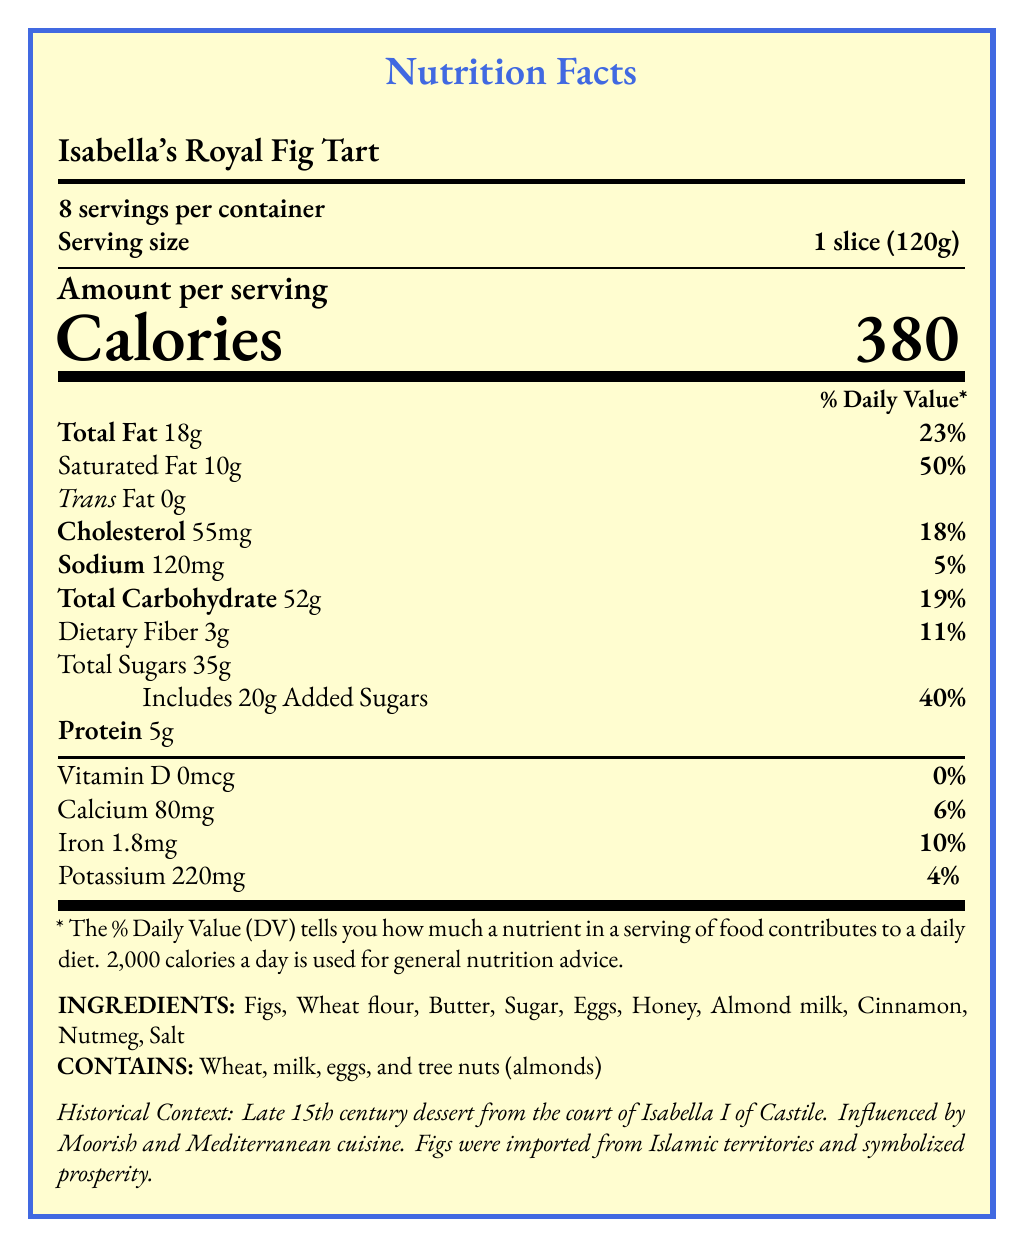what is the serving size? The serving size is clearly stated in the document as 1 slice (120g).
Answer: 1 slice (120g) how many calories are in one serving? The document specifies that each serving contains 380 calories.
Answer: 380 List three main ingredients in Isabella's Royal Fig Tart. The ingredients are listed in the document, and three of the main ones are Figs, Wheat flour, and Butter.
Answer: Figs, Wheat flour, Butter what percentage of the daily value for saturated fat does one serving provide? The document states that one serving contains 10g of saturated fat which is 50% of the daily value.
Answer: 50% what is the historical context of Isabella's Royal Fig Tart? The document includes a section on historical context which details that this tart was a late 15th-century dessert from the court of Isabella I of Castile and was influenced by Moorish and Mediterranean cuisine.
Answer: Late 15th century dessert from the court of Isabella I of Castile, influenced by Moorish and Mediterranean cuisine. how many servings per container are there? The document specifies that there are 8 servings per container.
Answer: 8 What allergens are contained in Isabella’s Royal Fig Tart? A. Wheat, tree nuts, fish B. Tree nuts, eggs, soy C. Wheat, milk, eggs, tree nuts D. Milk, soy, fish The document under allergens section specifies that it contains Wheat, milk, eggs, and tree nuts (almonds).
Answer: C What is the percentage daily value of added sugars in one serving? A. 20% B. 35% C. 40% D. 50% The document lists that added sugars make up 40% of the daily value per serving.
Answer: C Does Isabella’s Royal Fig Tart contain any trans fat? The document specifically states that the trans fat content is 0g.
Answer: No Summarize the nutrition facts of Isabella's Royal Fig Tart. The document provides detailed nutritional information, including calories, total fat, saturated fat, and other nutritional content, along with ingredients and historical context related to the dessert's origin and cultural significance.
Answer: Isabella's Royal Fig Tart offers 380 calories per serving, with each serving being 1 slice (120g). It contains 18g of total fat (23% DV) and 10g of saturated fat (50% DV). There is no trans fat. Cholesterol is 55mg (18% DV), sodium is 120mg (5% DV), and total carbohydrates are 52g (19% DV), including 3g dietary fiber (11% DV) and 35g total sugars with 20g added sugars (40% DV). Protein content is 5g. The tart also provides calcium (6% DV), iron (10% DV), and potassium (4% DV). Key ingredients include figs, wheat flour, butter, sugar, eggs, honey, and almond milk. It contains allergens like wheat, milk, eggs, and tree nuts (almonds). This 15th-century dessert is influenced by Moorish and Mediterranean cuisine and is significant for its prosperity symbolization. Is the tart suitable for fasting days in the Catholic calendar? The document explicitly states that the tart is not suitable for fasting days in the Catholic calendar.
Answer: No What is the preparation method for Isabella’s Royal Fig Tart? The document mentions that the preparation method is baking in a wood-fired oven.
Answer: Baked in a wood-fired oven Which monarch's court is associated with the origin of Isabella's Royal Fig Tart? The historical context in the document specifies that the tart is associated with the court of Isabella I of Castile.
Answer: Isabella I of Castile how much protein is in each serving? The document states that each serving contains 5g of protein.
Answer: 5g What type of wine is served with Isabella’s Royal Fig Tart? The document mentions that the tart is served with spiced wine, referred to as vino especiado.
Answer: Spiced wine (vino especiado) Where were the figs in Isabella’s Royal Fig Tart imported from? The document notes in the historical context that the figs were imported from Islamic territories.
Answer: Islamic territories What is the era associated with Isabella’s Royal Fig Tart? The document specifies that the tart is from the late 15th century.
Answer: Late 15th century What is the culinary influence on Isabella’s Royal Fig Tart? The document highlights that the tart is influenced by Moorish and Mediterranean cuisine.
Answer: Moorish and Mediterranean What is the total sugar content in one serving of the tart, and how much of this is from added sugars? The document clearly breaks down the total sugars into 35g, with 20g of these being added sugars.
Answer: Total sugars: 35g; Added sugars: 20g What specific historical significance does the fig hold in Isabella’s Royal Fig Tart? The document notes that figs symbolized prosperity and were often served at important royal functions.
Answer: Figs symbolized prosperity and were often served at important royal functions. What are the dietary considerations mentioned for Isabella’s Royal Fig Tart? The document clearly states that the tart is not suitable for fasting days in the Catholic calendar.
Answer: Not suitable for fasting days in the Catholic calendar. what percentage of the daily value for calcium does one serving provide? The document specifies that one serving provides 6% of the daily value for calcium.
Answer: 6% 